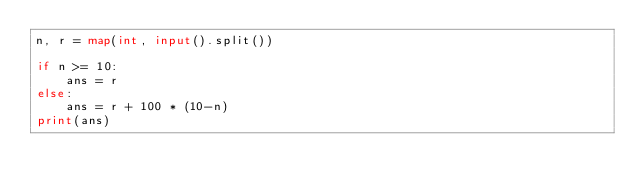Convert code to text. <code><loc_0><loc_0><loc_500><loc_500><_Python_>n, r = map(int, input().split())

if n >= 10:
    ans = r
else:
    ans = r + 100 * (10-n)
print(ans)</code> 